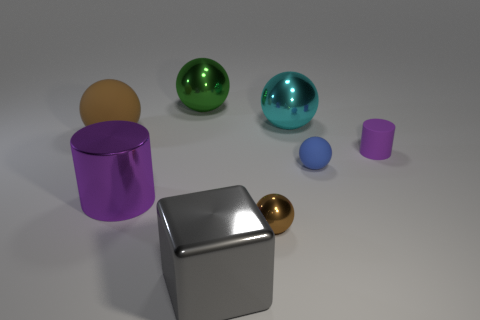What is the shape of the thing that is the same color as the metallic cylinder?
Your answer should be very brief. Cylinder. What number of objects are either purple matte cylinders or big brown blocks?
Your answer should be compact. 1. Does the purple thing that is on the left side of the green metal thing have the same size as the tiny brown thing?
Provide a succinct answer. No. What number of other things are the same size as the green object?
Provide a succinct answer. 4. Are any large green balls visible?
Offer a very short reply. Yes. There is a purple cylinder on the right side of the cylinder that is left of the large cyan object; how big is it?
Your answer should be very brief. Small. Do the tiny rubber object to the right of the tiny blue thing and the cylinder left of the purple matte cylinder have the same color?
Offer a terse response. Yes. There is a rubber object that is both on the right side of the tiny brown sphere and behind the blue rubber ball; what is its color?
Provide a succinct answer. Purple. How many other objects are the same shape as the gray object?
Your answer should be very brief. 0. What is the color of the shiny thing that is the same size as the purple matte cylinder?
Keep it short and to the point. Brown. 